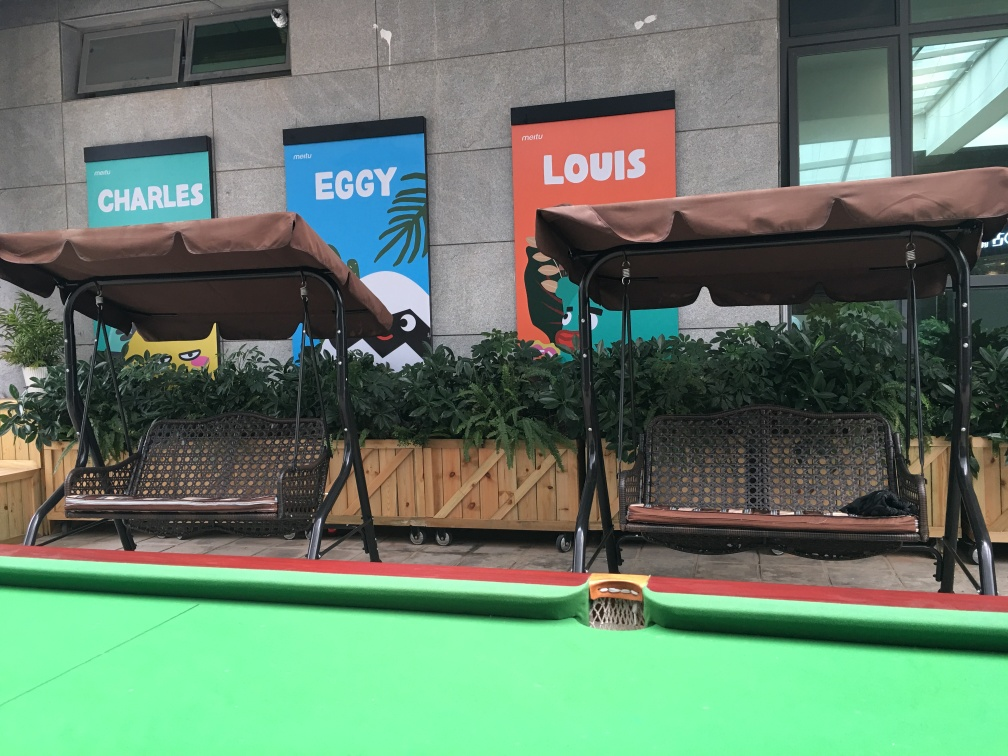What is the main subject of the image? The image features two outdoor swing benches positioned on a green carpeted area. Behind the benches are decorative pot plants and three fun, themed signs that read 'CHARLES', 'EGGY', and 'LOUIS', possibly alluding to a playful, pet-friendly or family-oriented place. The benches provide a communal space for relaxation and socializing. 